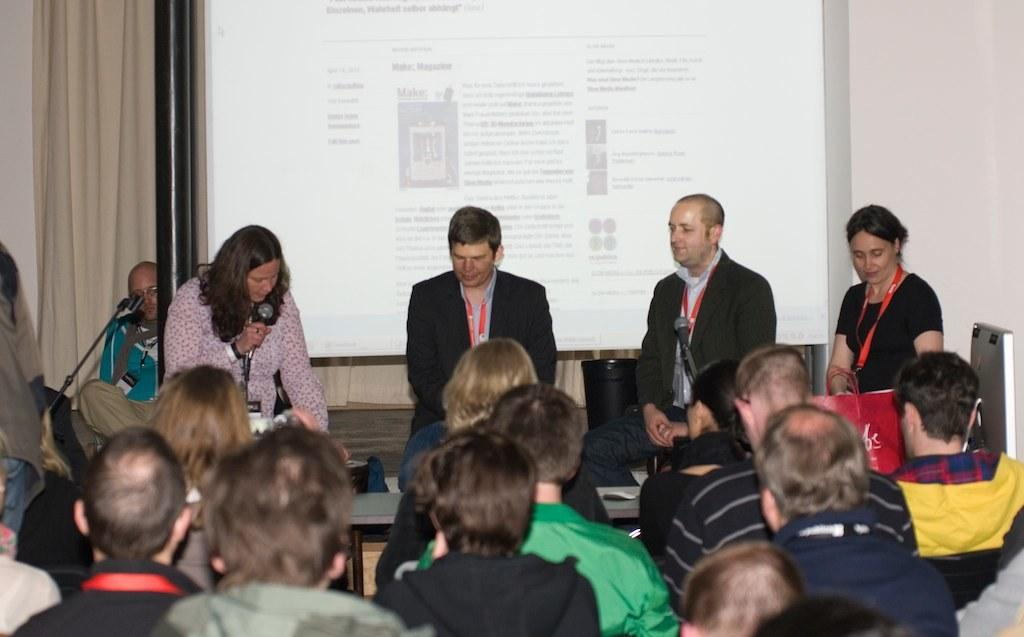How many people are in the image? There is a group of people in the image, but the exact number is not specified. What objects are present in the image that might be used for amplifying sound? There are microphones in the image. What piece of furniture is visible in the image? There is a table in the image. What object is present in the image for disposing of waste? There is a dustbin in the image. What type of bag can be seen in the image? There is a bag in the image, but its contents or purpose are not specified. What can be seen in the background of the image? There is a wall, a projector screen, a curtain, and a pole in the background of the image. What type of throat can be seen on the projector screen in the image? There is no throat visible on the projector screen in the image. What type of bubble is floating above the group of people in the image? There are no bubbles present in the image. 